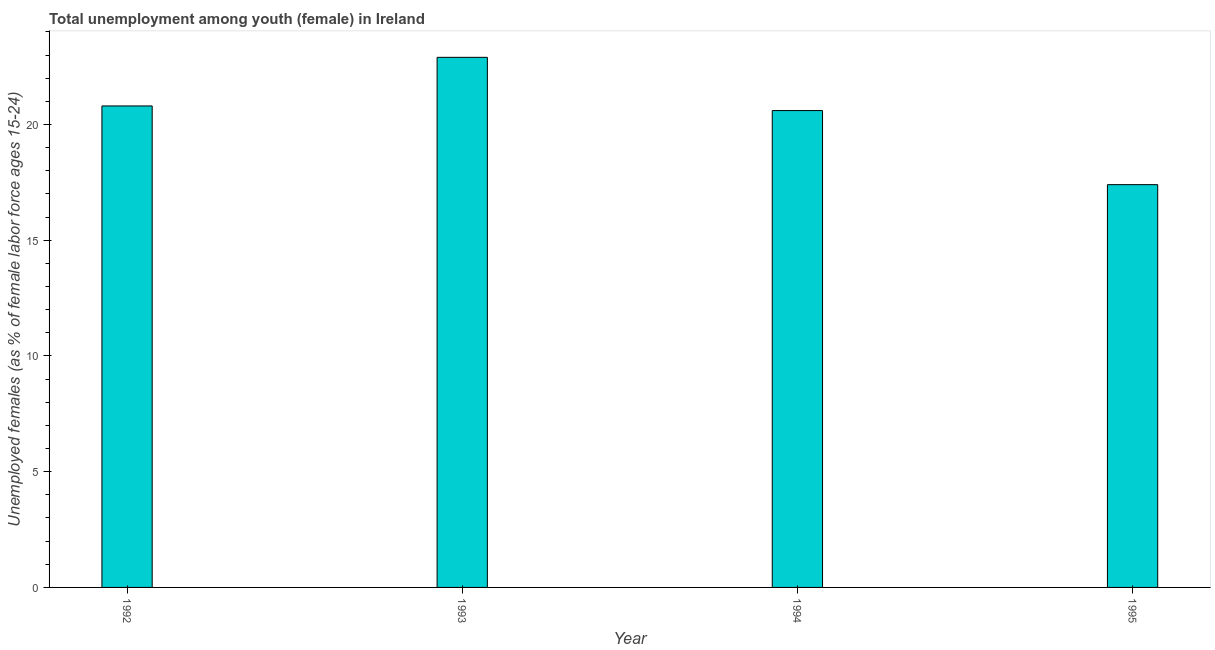What is the title of the graph?
Offer a terse response. Total unemployment among youth (female) in Ireland. What is the label or title of the Y-axis?
Make the answer very short. Unemployed females (as % of female labor force ages 15-24). What is the unemployed female youth population in 1992?
Ensure brevity in your answer.  20.8. Across all years, what is the maximum unemployed female youth population?
Your answer should be compact. 22.9. Across all years, what is the minimum unemployed female youth population?
Provide a short and direct response. 17.4. In which year was the unemployed female youth population maximum?
Make the answer very short. 1993. What is the sum of the unemployed female youth population?
Your answer should be compact. 81.7. What is the difference between the unemployed female youth population in 1994 and 1995?
Your response must be concise. 3.2. What is the average unemployed female youth population per year?
Offer a very short reply. 20.43. What is the median unemployed female youth population?
Your response must be concise. 20.7. In how many years, is the unemployed female youth population greater than 13 %?
Ensure brevity in your answer.  4. What is the ratio of the unemployed female youth population in 1994 to that in 1995?
Keep it short and to the point. 1.18. Is the unemployed female youth population in 1992 less than that in 1994?
Provide a short and direct response. No. Is the sum of the unemployed female youth population in 1992 and 1995 greater than the maximum unemployed female youth population across all years?
Give a very brief answer. Yes. What is the difference between the highest and the lowest unemployed female youth population?
Provide a succinct answer. 5.5. In how many years, is the unemployed female youth population greater than the average unemployed female youth population taken over all years?
Keep it short and to the point. 3. How many bars are there?
Provide a short and direct response. 4. Are all the bars in the graph horizontal?
Your answer should be very brief. No. What is the difference between two consecutive major ticks on the Y-axis?
Your answer should be very brief. 5. Are the values on the major ticks of Y-axis written in scientific E-notation?
Keep it short and to the point. No. What is the Unemployed females (as % of female labor force ages 15-24) in 1992?
Your response must be concise. 20.8. What is the Unemployed females (as % of female labor force ages 15-24) of 1993?
Give a very brief answer. 22.9. What is the Unemployed females (as % of female labor force ages 15-24) of 1994?
Give a very brief answer. 20.6. What is the Unemployed females (as % of female labor force ages 15-24) of 1995?
Offer a terse response. 17.4. What is the difference between the Unemployed females (as % of female labor force ages 15-24) in 1992 and 1993?
Your answer should be compact. -2.1. What is the difference between the Unemployed females (as % of female labor force ages 15-24) in 1992 and 1995?
Your answer should be compact. 3.4. What is the difference between the Unemployed females (as % of female labor force ages 15-24) in 1994 and 1995?
Give a very brief answer. 3.2. What is the ratio of the Unemployed females (as % of female labor force ages 15-24) in 1992 to that in 1993?
Give a very brief answer. 0.91. What is the ratio of the Unemployed females (as % of female labor force ages 15-24) in 1992 to that in 1995?
Keep it short and to the point. 1.2. What is the ratio of the Unemployed females (as % of female labor force ages 15-24) in 1993 to that in 1994?
Provide a short and direct response. 1.11. What is the ratio of the Unemployed females (as % of female labor force ages 15-24) in 1993 to that in 1995?
Offer a terse response. 1.32. What is the ratio of the Unemployed females (as % of female labor force ages 15-24) in 1994 to that in 1995?
Ensure brevity in your answer.  1.18. 